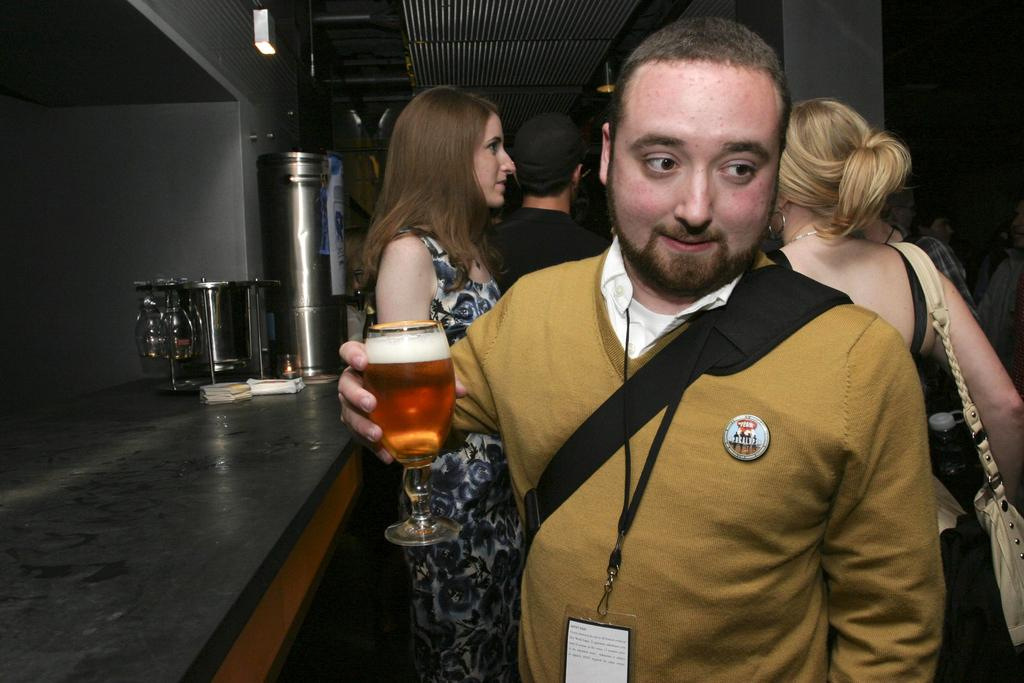Who is the main subject in the image? There is a man in the image. What is the man holding in the image? The man is holding a wine glass. Can you describe the people behind the man? There are people behind the man, but their specific features or actions are not mentioned in the facts. What can be seen on the left side of the image? There are glasses on the left side of the image. What type of butter is being used to blow the secretary's hair in the image? There is no butter, secretary, or blowing of hair present in the image. 